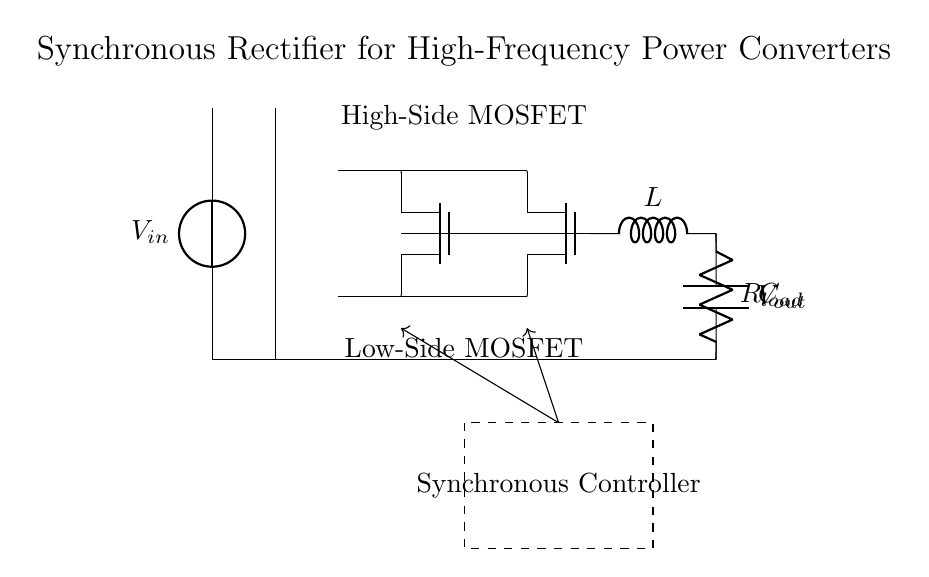What is the input voltage source labeled as? The input voltage source is labeled as V_in, indicating it is the source of input voltage for the circuit.
Answer: V_in What type of MOSFETs are used in this circuit? The circuit diagram shows two Tnmos components, indicating that N-channel MOSFETs are used for the synchronous rectifier.
Answer: Tnmos What is the function of the inductor in this circuit? The inductor labeled as L is used to store energy and smooth the output current, which helps in maintaining a stable voltage across the load.
Answer: Store energy How many active switching devices are present in this synchronous rectifier? There are two N-channel MOSFETs (Q1 and Q2) functioning as the active switching devices in the synchronous rectifier circuit.
Answer: Two What component is represented by R_load? R_load represents the load resistor in the circuit, where the output voltage is applied, and which consumes the power delivered by the converter.
Answer: Load resistor What is the primary role of the synchronous controller? The synchronous controller manages the operation of the MOSFETs (Q1 and Q2) to regulate their switching, ensuring efficiency by reducing voltage drops.
Answer: Manage MOSFETs Why is a synchronous rectifier preferred for high-frequency applications? Synchronous rectifiers reduce conduction losses compared to traditional diode rectifiers, improving efficiency, especially at high switching frequencies typical in power converters.
Answer: Improve efficiency 